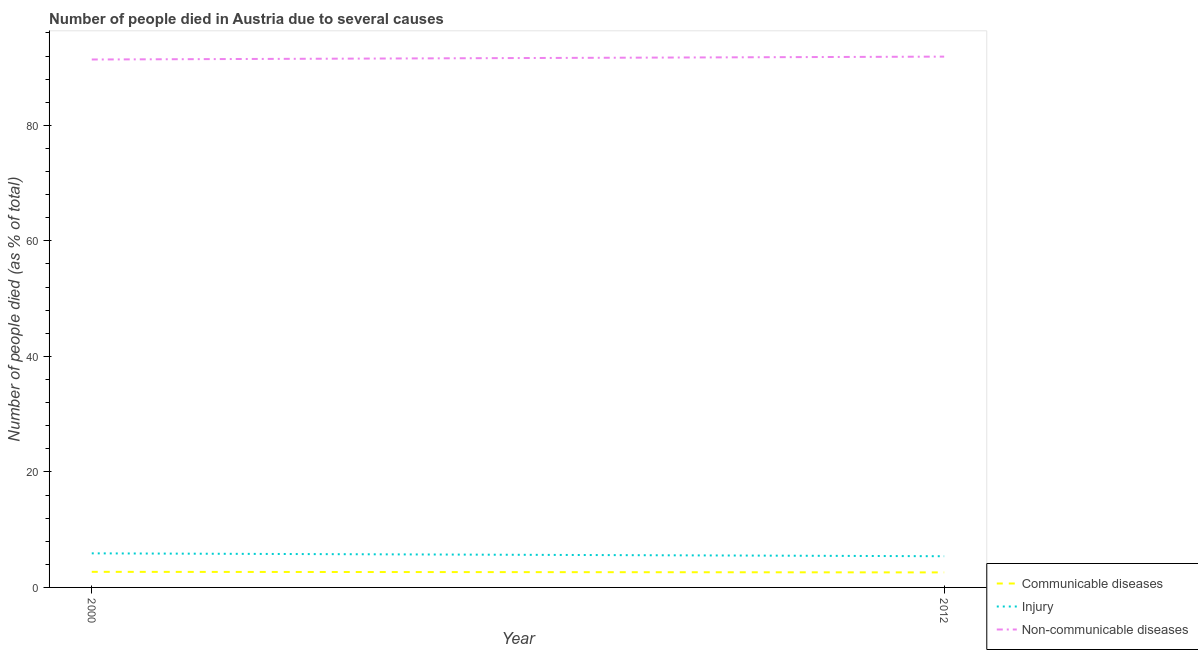Does the line corresponding to number of people who dies of non-communicable diseases intersect with the line corresponding to number of people who died of communicable diseases?
Give a very brief answer. No. Is the number of lines equal to the number of legend labels?
Offer a terse response. Yes. What is the number of people who dies of non-communicable diseases in 2000?
Offer a terse response. 91.4. Across all years, what is the maximum number of people who died of communicable diseases?
Keep it short and to the point. 2.7. Across all years, what is the minimum number of people who dies of non-communicable diseases?
Make the answer very short. 91.4. What is the total number of people who died of injury in the graph?
Offer a terse response. 11.3. What is the difference between the number of people who died of communicable diseases in 2000 and that in 2012?
Offer a very short reply. 0.1. What is the difference between the number of people who died of communicable diseases in 2012 and the number of people who dies of non-communicable diseases in 2000?
Ensure brevity in your answer.  -88.8. What is the average number of people who died of communicable diseases per year?
Your response must be concise. 2.65. In the year 2012, what is the difference between the number of people who dies of non-communicable diseases and number of people who died of injury?
Offer a very short reply. 86.5. What is the ratio of the number of people who died of injury in 2000 to that in 2012?
Offer a terse response. 1.09. Is the number of people who dies of non-communicable diseases in 2000 less than that in 2012?
Your answer should be very brief. Yes. In how many years, is the number of people who died of communicable diseases greater than the average number of people who died of communicable diseases taken over all years?
Provide a short and direct response. 1. Does the number of people who died of injury monotonically increase over the years?
Provide a short and direct response. No. Is the number of people who dies of non-communicable diseases strictly greater than the number of people who died of communicable diseases over the years?
Provide a succinct answer. Yes. How many years are there in the graph?
Your answer should be very brief. 2. What is the difference between two consecutive major ticks on the Y-axis?
Provide a succinct answer. 20. Are the values on the major ticks of Y-axis written in scientific E-notation?
Provide a succinct answer. No. How many legend labels are there?
Your response must be concise. 3. How are the legend labels stacked?
Offer a terse response. Vertical. What is the title of the graph?
Give a very brief answer. Number of people died in Austria due to several causes. What is the label or title of the X-axis?
Provide a short and direct response. Year. What is the label or title of the Y-axis?
Keep it short and to the point. Number of people died (as % of total). What is the Number of people died (as % of total) in Communicable diseases in 2000?
Your answer should be compact. 2.7. What is the Number of people died (as % of total) in Non-communicable diseases in 2000?
Provide a succinct answer. 91.4. What is the Number of people died (as % of total) of Communicable diseases in 2012?
Ensure brevity in your answer.  2.6. What is the Number of people died (as % of total) in Injury in 2012?
Give a very brief answer. 5.4. What is the Number of people died (as % of total) in Non-communicable diseases in 2012?
Your response must be concise. 91.9. Across all years, what is the maximum Number of people died (as % of total) of Injury?
Your answer should be compact. 5.9. Across all years, what is the maximum Number of people died (as % of total) of Non-communicable diseases?
Keep it short and to the point. 91.9. Across all years, what is the minimum Number of people died (as % of total) of Non-communicable diseases?
Make the answer very short. 91.4. What is the total Number of people died (as % of total) in Non-communicable diseases in the graph?
Your response must be concise. 183.3. What is the difference between the Number of people died (as % of total) in Communicable diseases in 2000 and that in 2012?
Offer a terse response. 0.1. What is the difference between the Number of people died (as % of total) in Communicable diseases in 2000 and the Number of people died (as % of total) in Injury in 2012?
Ensure brevity in your answer.  -2.7. What is the difference between the Number of people died (as % of total) of Communicable diseases in 2000 and the Number of people died (as % of total) of Non-communicable diseases in 2012?
Your answer should be compact. -89.2. What is the difference between the Number of people died (as % of total) in Injury in 2000 and the Number of people died (as % of total) in Non-communicable diseases in 2012?
Your answer should be very brief. -86. What is the average Number of people died (as % of total) in Communicable diseases per year?
Offer a terse response. 2.65. What is the average Number of people died (as % of total) of Injury per year?
Provide a succinct answer. 5.65. What is the average Number of people died (as % of total) of Non-communicable diseases per year?
Your response must be concise. 91.65. In the year 2000, what is the difference between the Number of people died (as % of total) in Communicable diseases and Number of people died (as % of total) in Non-communicable diseases?
Provide a short and direct response. -88.7. In the year 2000, what is the difference between the Number of people died (as % of total) in Injury and Number of people died (as % of total) in Non-communicable diseases?
Provide a short and direct response. -85.5. In the year 2012, what is the difference between the Number of people died (as % of total) in Communicable diseases and Number of people died (as % of total) in Non-communicable diseases?
Provide a short and direct response. -89.3. In the year 2012, what is the difference between the Number of people died (as % of total) of Injury and Number of people died (as % of total) of Non-communicable diseases?
Provide a short and direct response. -86.5. What is the ratio of the Number of people died (as % of total) in Communicable diseases in 2000 to that in 2012?
Give a very brief answer. 1.04. What is the ratio of the Number of people died (as % of total) of Injury in 2000 to that in 2012?
Provide a succinct answer. 1.09. What is the difference between the highest and the second highest Number of people died (as % of total) in Injury?
Provide a succinct answer. 0.5. What is the difference between the highest and the second highest Number of people died (as % of total) of Non-communicable diseases?
Make the answer very short. 0.5. What is the difference between the highest and the lowest Number of people died (as % of total) of Injury?
Provide a succinct answer. 0.5. What is the difference between the highest and the lowest Number of people died (as % of total) of Non-communicable diseases?
Ensure brevity in your answer.  0.5. 